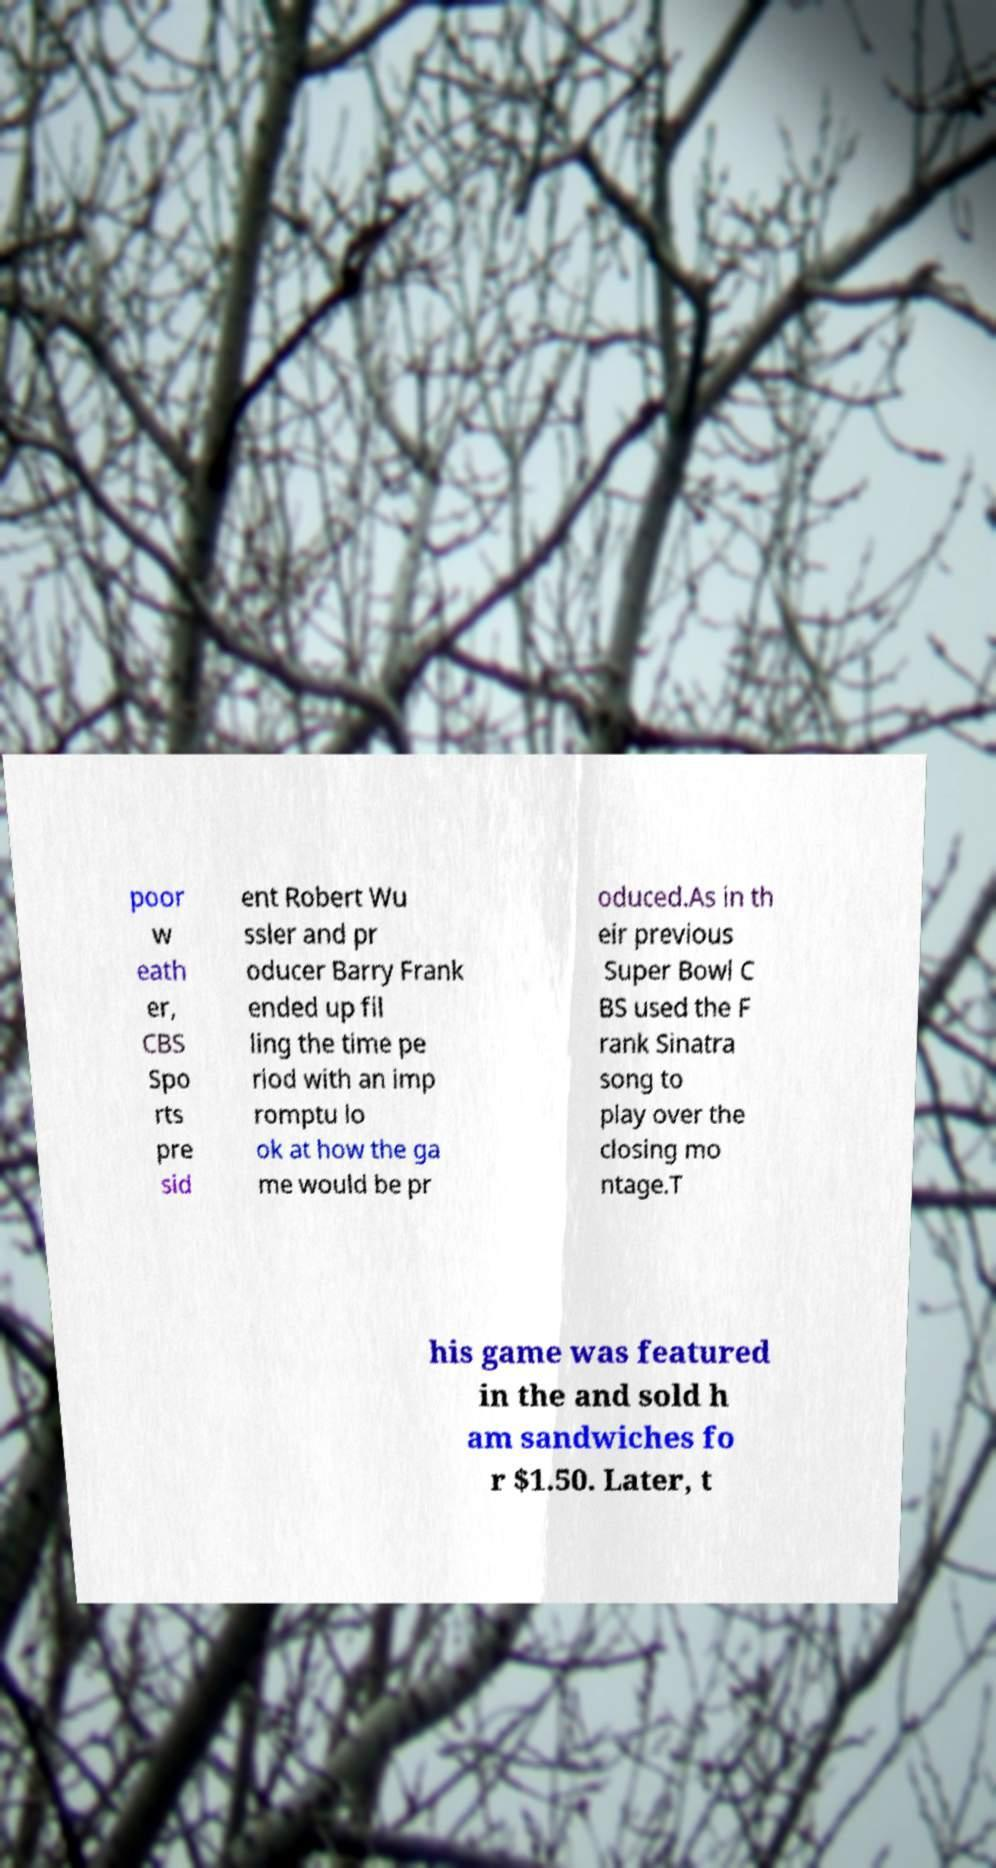Could you extract and type out the text from this image? poor w eath er, CBS Spo rts pre sid ent Robert Wu ssler and pr oducer Barry Frank ended up fil ling the time pe riod with an imp romptu lo ok at how the ga me would be pr oduced.As in th eir previous Super Bowl C BS used the F rank Sinatra song to play over the closing mo ntage.T his game was featured in the and sold h am sandwiches fo r $1.50. Later, t 